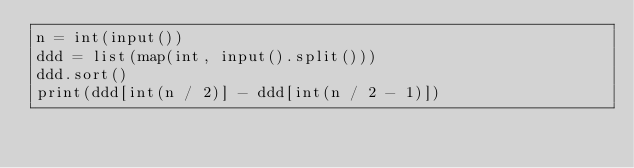Convert code to text. <code><loc_0><loc_0><loc_500><loc_500><_Python_>n = int(input())
ddd = list(map(int, input().split()))
ddd.sort()
print(ddd[int(n / 2)] - ddd[int(n / 2 - 1)])</code> 